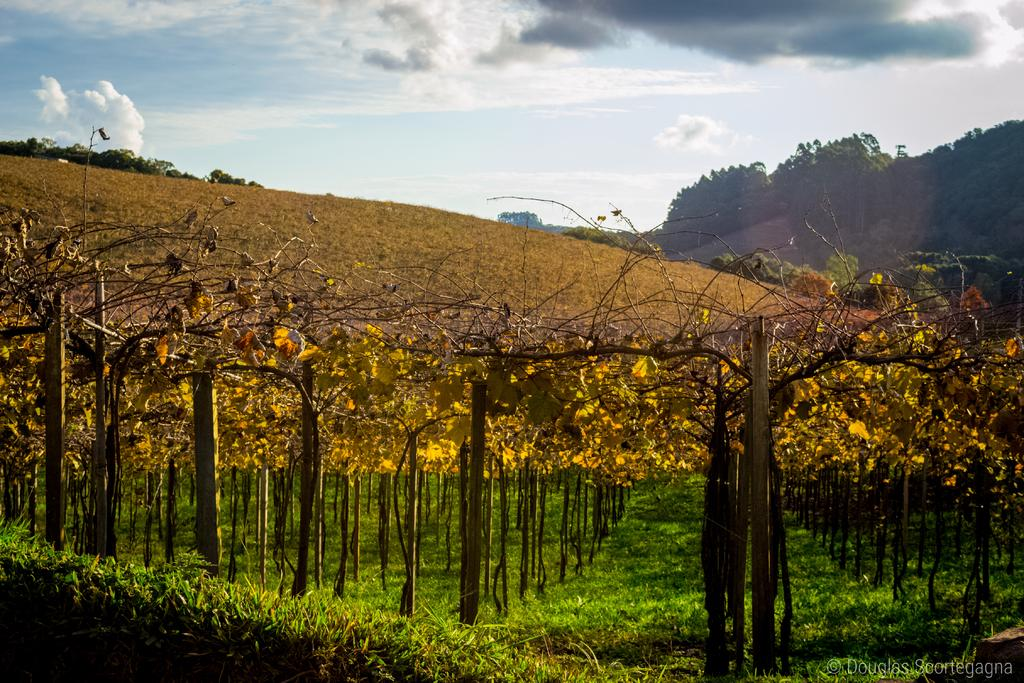What type of ground surface is visible in the image? There is grass on the ground in the image. What can be seen in the image besides grass? There are trees in the image, with some being yellow in color. What is visible in the background of the image? There are mountains, trees, and the sky visible in the background of the image. What type of zipper can be seen on the trees in the image? There are no zippers present on the trees in the image. 